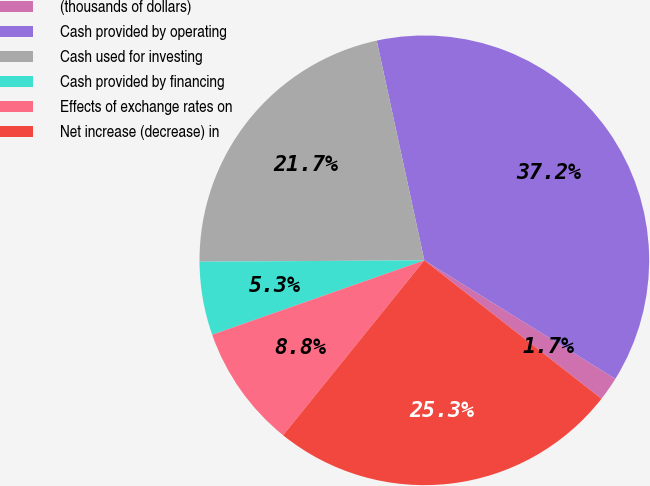Convert chart. <chart><loc_0><loc_0><loc_500><loc_500><pie_chart><fcel>(thousands of dollars)<fcel>Cash provided by operating<fcel>Cash used for investing<fcel>Cash provided by financing<fcel>Effects of exchange rates on<fcel>Net increase (decrease) in<nl><fcel>1.72%<fcel>37.23%<fcel>21.7%<fcel>5.27%<fcel>8.82%<fcel>25.25%<nl></chart> 